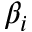<formula> <loc_0><loc_0><loc_500><loc_500>\beta _ { i }</formula> 